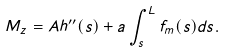Convert formula to latex. <formula><loc_0><loc_0><loc_500><loc_500>M _ { z } = A h ^ { \prime \prime } ( s ) + a \int _ { s } ^ { L } f _ { m } ( s ) d s .</formula> 